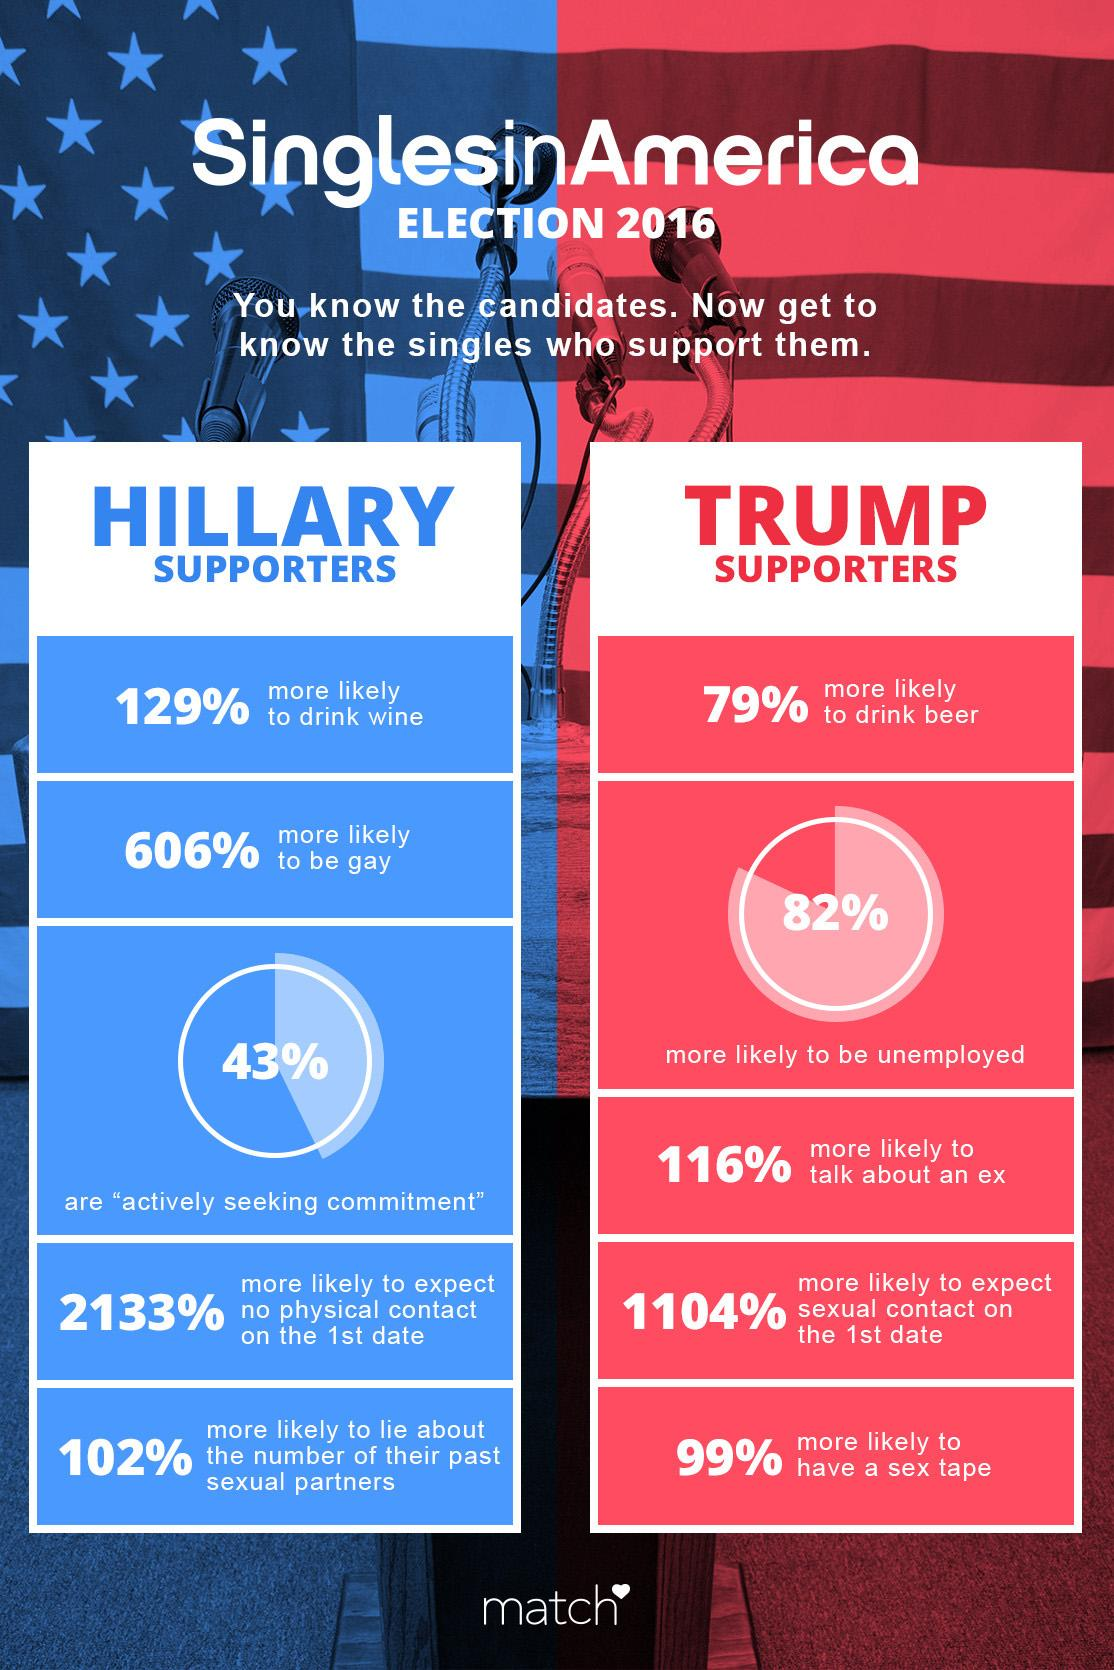Specify some key components in this picture. In the 2016 elections, 43% of Hillary supporters were actively seeking commitment. According to a survey conducted during the 2016 elections, 82% of Trump supporters were more likely to be unemployed. It is estimated that 99% of Trump supporters from the 2016 elections are more likely to have a sex tape. 